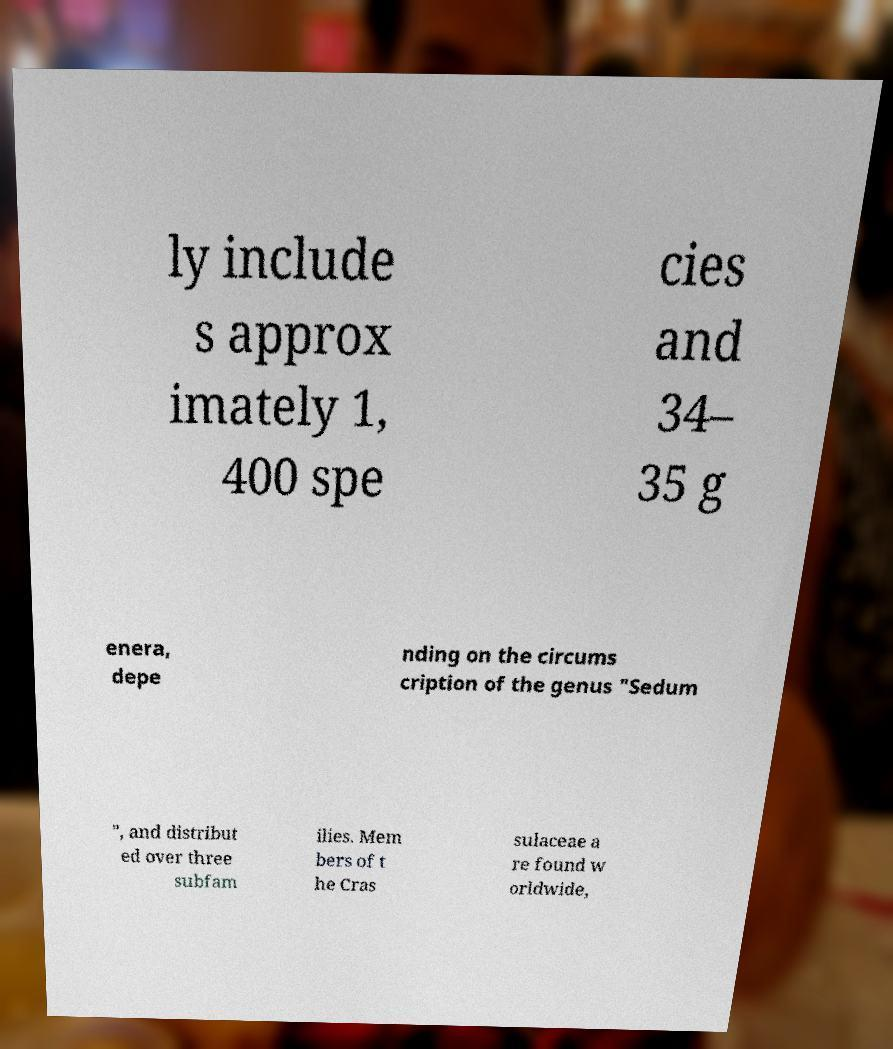Please identify and transcribe the text found in this image. ly include s approx imately 1, 400 spe cies and 34– 35 g enera, depe nding on the circums cription of the genus "Sedum ", and distribut ed over three subfam ilies. Mem bers of t he Cras sulaceae a re found w orldwide, 